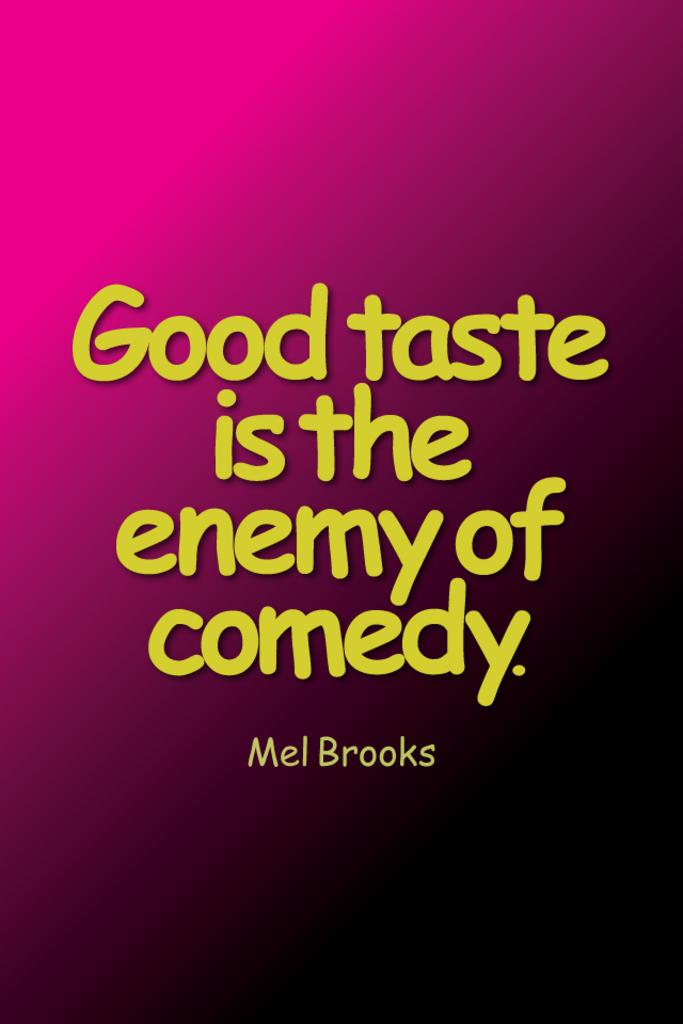<image>
Describe the image concisely. A Mel Brooks quote says that good taste is the enemy of comedy. 